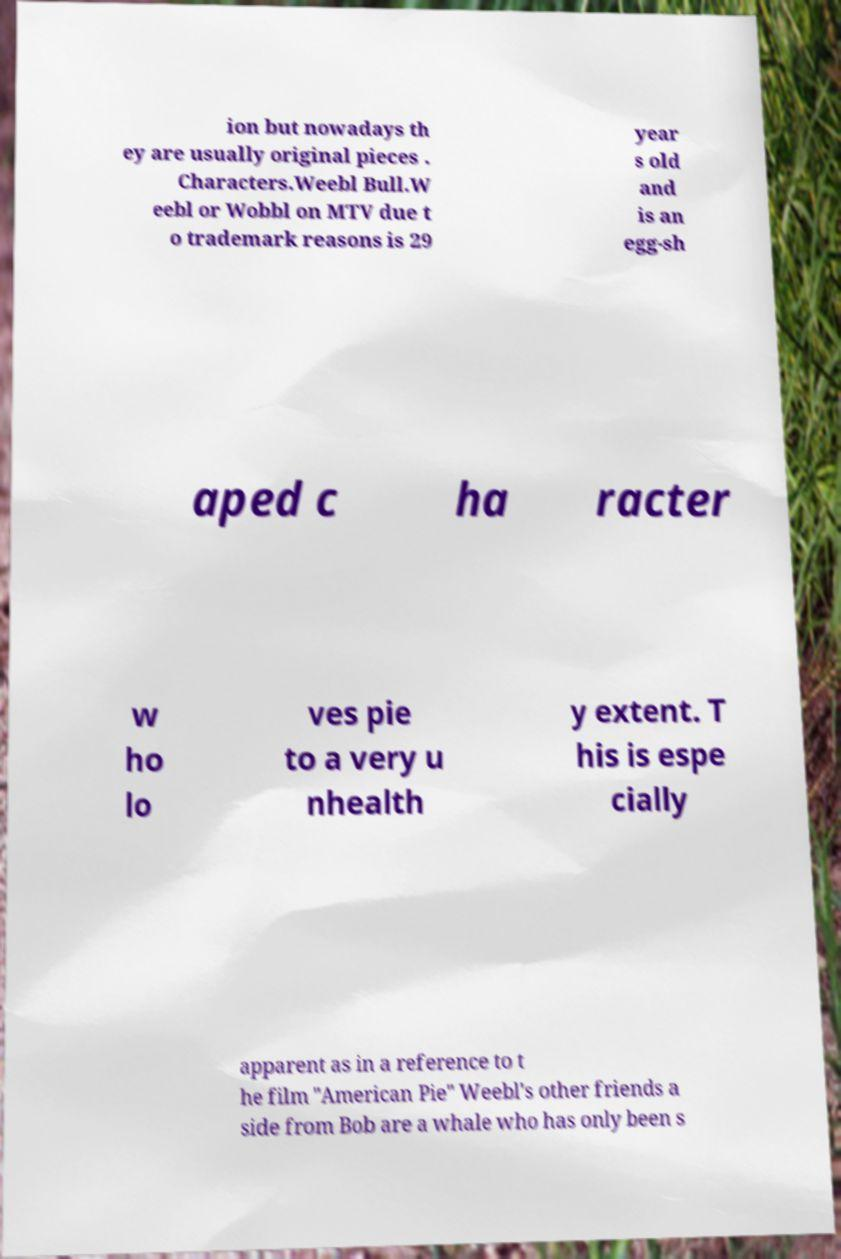I need the written content from this picture converted into text. Can you do that? ion but nowadays th ey are usually original pieces . Characters.Weebl Bull.W eebl or Wobbl on MTV due t o trademark reasons is 29 year s old and is an egg-sh aped c ha racter w ho lo ves pie to a very u nhealth y extent. T his is espe cially apparent as in a reference to t he film "American Pie" Weebl's other friends a side from Bob are a whale who has only been s 